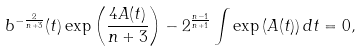Convert formula to latex. <formula><loc_0><loc_0><loc_500><loc_500>b ^ { - \frac { 2 } { n + 3 } } ( t ) \exp \left ( \frac { 4 A ( t ) } { n + 3 } \right ) - 2 ^ { \frac { n - 1 } { n + 1 } } \int \exp \left ( A ( t ) \right ) d t = 0 ,</formula> 